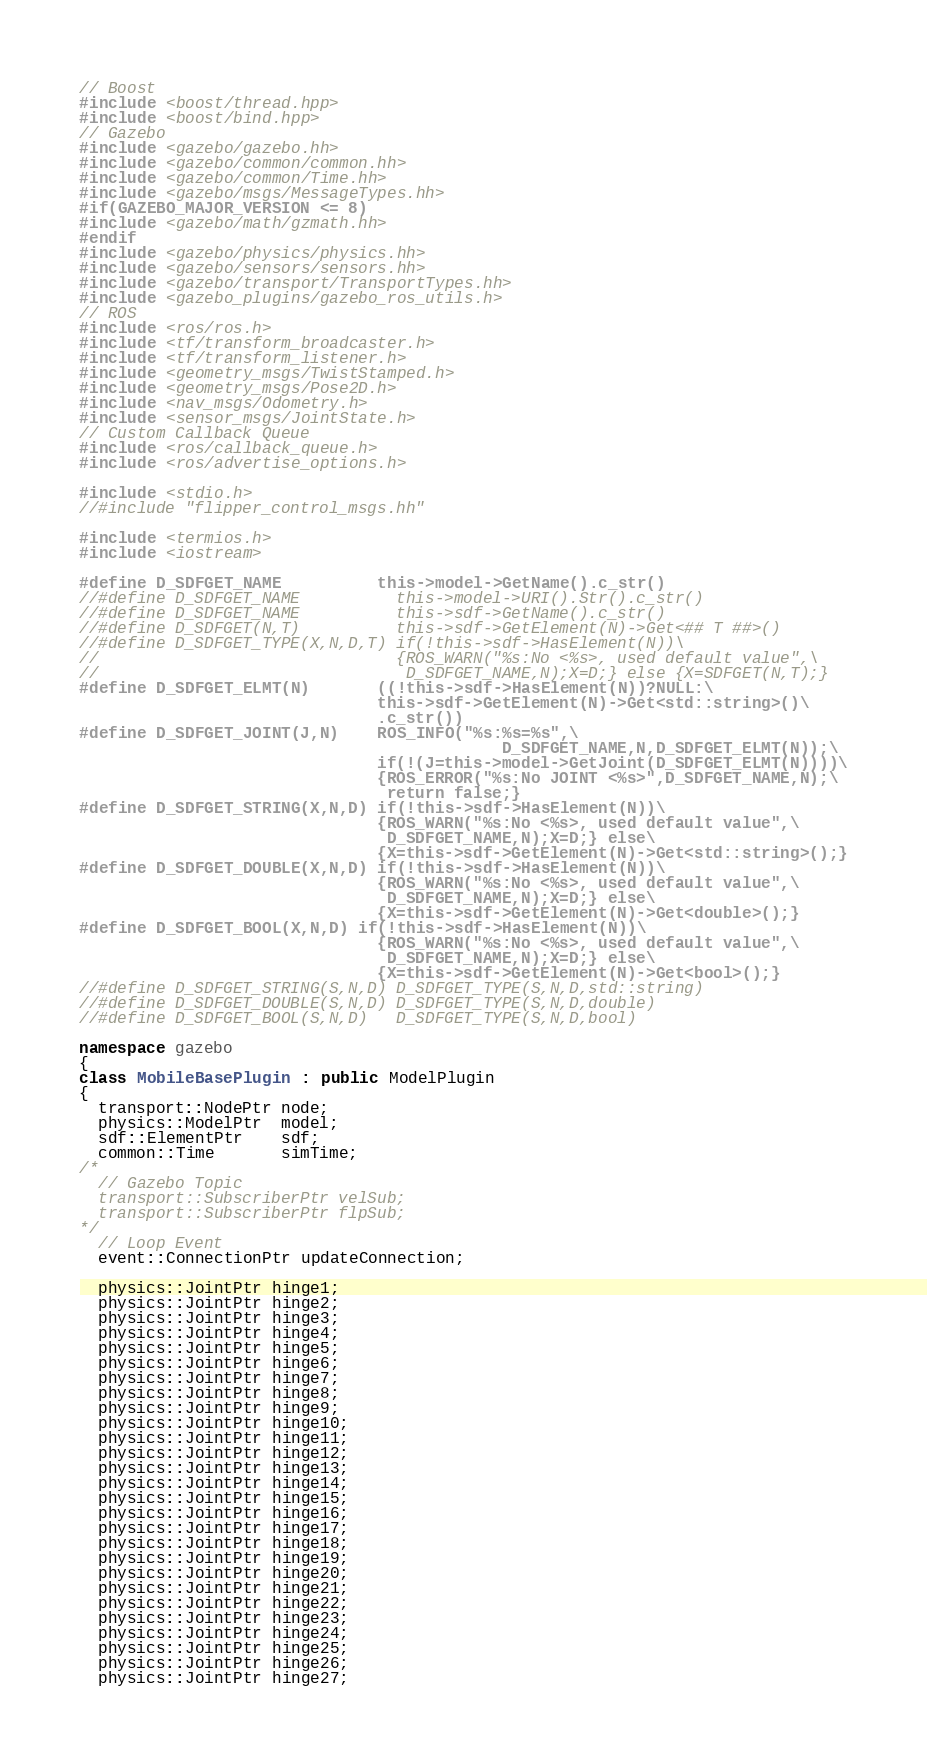<code> <loc_0><loc_0><loc_500><loc_500><_C++_>// Boost
#include <boost/thread.hpp>
#include <boost/bind.hpp>
// Gazebo
#include <gazebo/gazebo.hh>
#include <gazebo/common/common.hh>
#include <gazebo/common/Time.hh>
#include <gazebo/msgs/MessageTypes.hh>
#if(GAZEBO_MAJOR_VERSION <= 8)
#include <gazebo/math/gzmath.hh>
#endif
#include <gazebo/physics/physics.hh>
#include <gazebo/sensors/sensors.hh>
#include <gazebo/transport/TransportTypes.hh>
#include <gazebo_plugins/gazebo_ros_utils.h>
// ROS
#include <ros/ros.h>
#include <tf/transform_broadcaster.h>
#include <tf/transform_listener.h>
#include <geometry_msgs/TwistStamped.h>
#include <geometry_msgs/Pose2D.h>
#include <nav_msgs/Odometry.h>
#include <sensor_msgs/JointState.h>
// Custom Callback Queue
#include <ros/callback_queue.h>
#include <ros/advertise_options.h>

#include <stdio.h>
//#include "flipper_control_msgs.hh"

#include <termios.h>
#include <iostream>

#define D_SDFGET_NAME          this->model->GetName().c_str()
//#define D_SDFGET_NAME          this->model->URI().Str().c_str()
//#define D_SDFGET_NAME          this->sdf->GetName().c_str()
//#define D_SDFGET(N,T)          this->sdf->GetElement(N)->Get<## T ##>()
//#define D_SDFGET_TYPE(X,N,D,T) if(!this->sdf->HasElement(N))\
//                               {ROS_WARN("%s:No <%s>, used default value",\
//                                D_SDFGET_NAME,N);X=D;} else {X=SDFGET(N,T);}
#define D_SDFGET_ELMT(N)       ((!this->sdf->HasElement(N))?NULL:\
                               this->sdf->GetElement(N)->Get<std::string>()\
                               .c_str())
#define D_SDFGET_JOINT(J,N)    ROS_INFO("%s:%s=%s",\
                                            D_SDFGET_NAME,N,D_SDFGET_ELMT(N));\
                               if(!(J=this->model->GetJoint(D_SDFGET_ELMT(N))))\
                               {ROS_ERROR("%s:No JOINT <%s>",D_SDFGET_NAME,N);\
                                return false;}
#define D_SDFGET_STRING(X,N,D) if(!this->sdf->HasElement(N))\
                               {ROS_WARN("%s:No <%s>, used default value",\
                                D_SDFGET_NAME,N);X=D;} else\
                               {X=this->sdf->GetElement(N)->Get<std::string>();}
#define D_SDFGET_DOUBLE(X,N,D) if(!this->sdf->HasElement(N))\
                               {ROS_WARN("%s:No <%s>, used default value",\
                                D_SDFGET_NAME,N);X=D;} else\
                               {X=this->sdf->GetElement(N)->Get<double>();}
#define D_SDFGET_BOOL(X,N,D) if(!this->sdf->HasElement(N))\
                               {ROS_WARN("%s:No <%s>, used default value",\
                                D_SDFGET_NAME,N);X=D;} else\
                               {X=this->sdf->GetElement(N)->Get<bool>();}
//#define D_SDFGET_STRING(S,N,D) D_SDFGET_TYPE(S,N,D,std::string)
//#define D_SDFGET_DOUBLE(S,N,D) D_SDFGET_TYPE(S,N,D,double)
//#define D_SDFGET_BOOL(S,N,D)   D_SDFGET_TYPE(S,N,D,bool)

namespace gazebo
{
class MobileBasePlugin : public ModelPlugin
{
  transport::NodePtr node;
  physics::ModelPtr  model;
  sdf::ElementPtr    sdf;
  common::Time       simTime;
/*
  // Gazebo Topic
  transport::SubscriberPtr velSub;
  transport::SubscriberPtr flpSub;
*/
  // Loop Event
  event::ConnectionPtr updateConnection;

  physics::JointPtr hinge1;
  physics::JointPtr hinge2;
  physics::JointPtr hinge3;
  physics::JointPtr hinge4;
  physics::JointPtr hinge5;
  physics::JointPtr hinge6;
  physics::JointPtr hinge7;
  physics::JointPtr hinge8;
  physics::JointPtr hinge9;
  physics::JointPtr hinge10;
  physics::JointPtr hinge11;
  physics::JointPtr hinge12;
  physics::JointPtr hinge13;
  physics::JointPtr hinge14;
  physics::JointPtr hinge15;
  physics::JointPtr hinge16;
  physics::JointPtr hinge17;
  physics::JointPtr hinge18;
  physics::JointPtr hinge19;
  physics::JointPtr hinge20;
  physics::JointPtr hinge21;
  physics::JointPtr hinge22;
  physics::JointPtr hinge23;
  physics::JointPtr hinge24;
  physics::JointPtr hinge25;
  physics::JointPtr hinge26;
  physics::JointPtr hinge27;</code> 